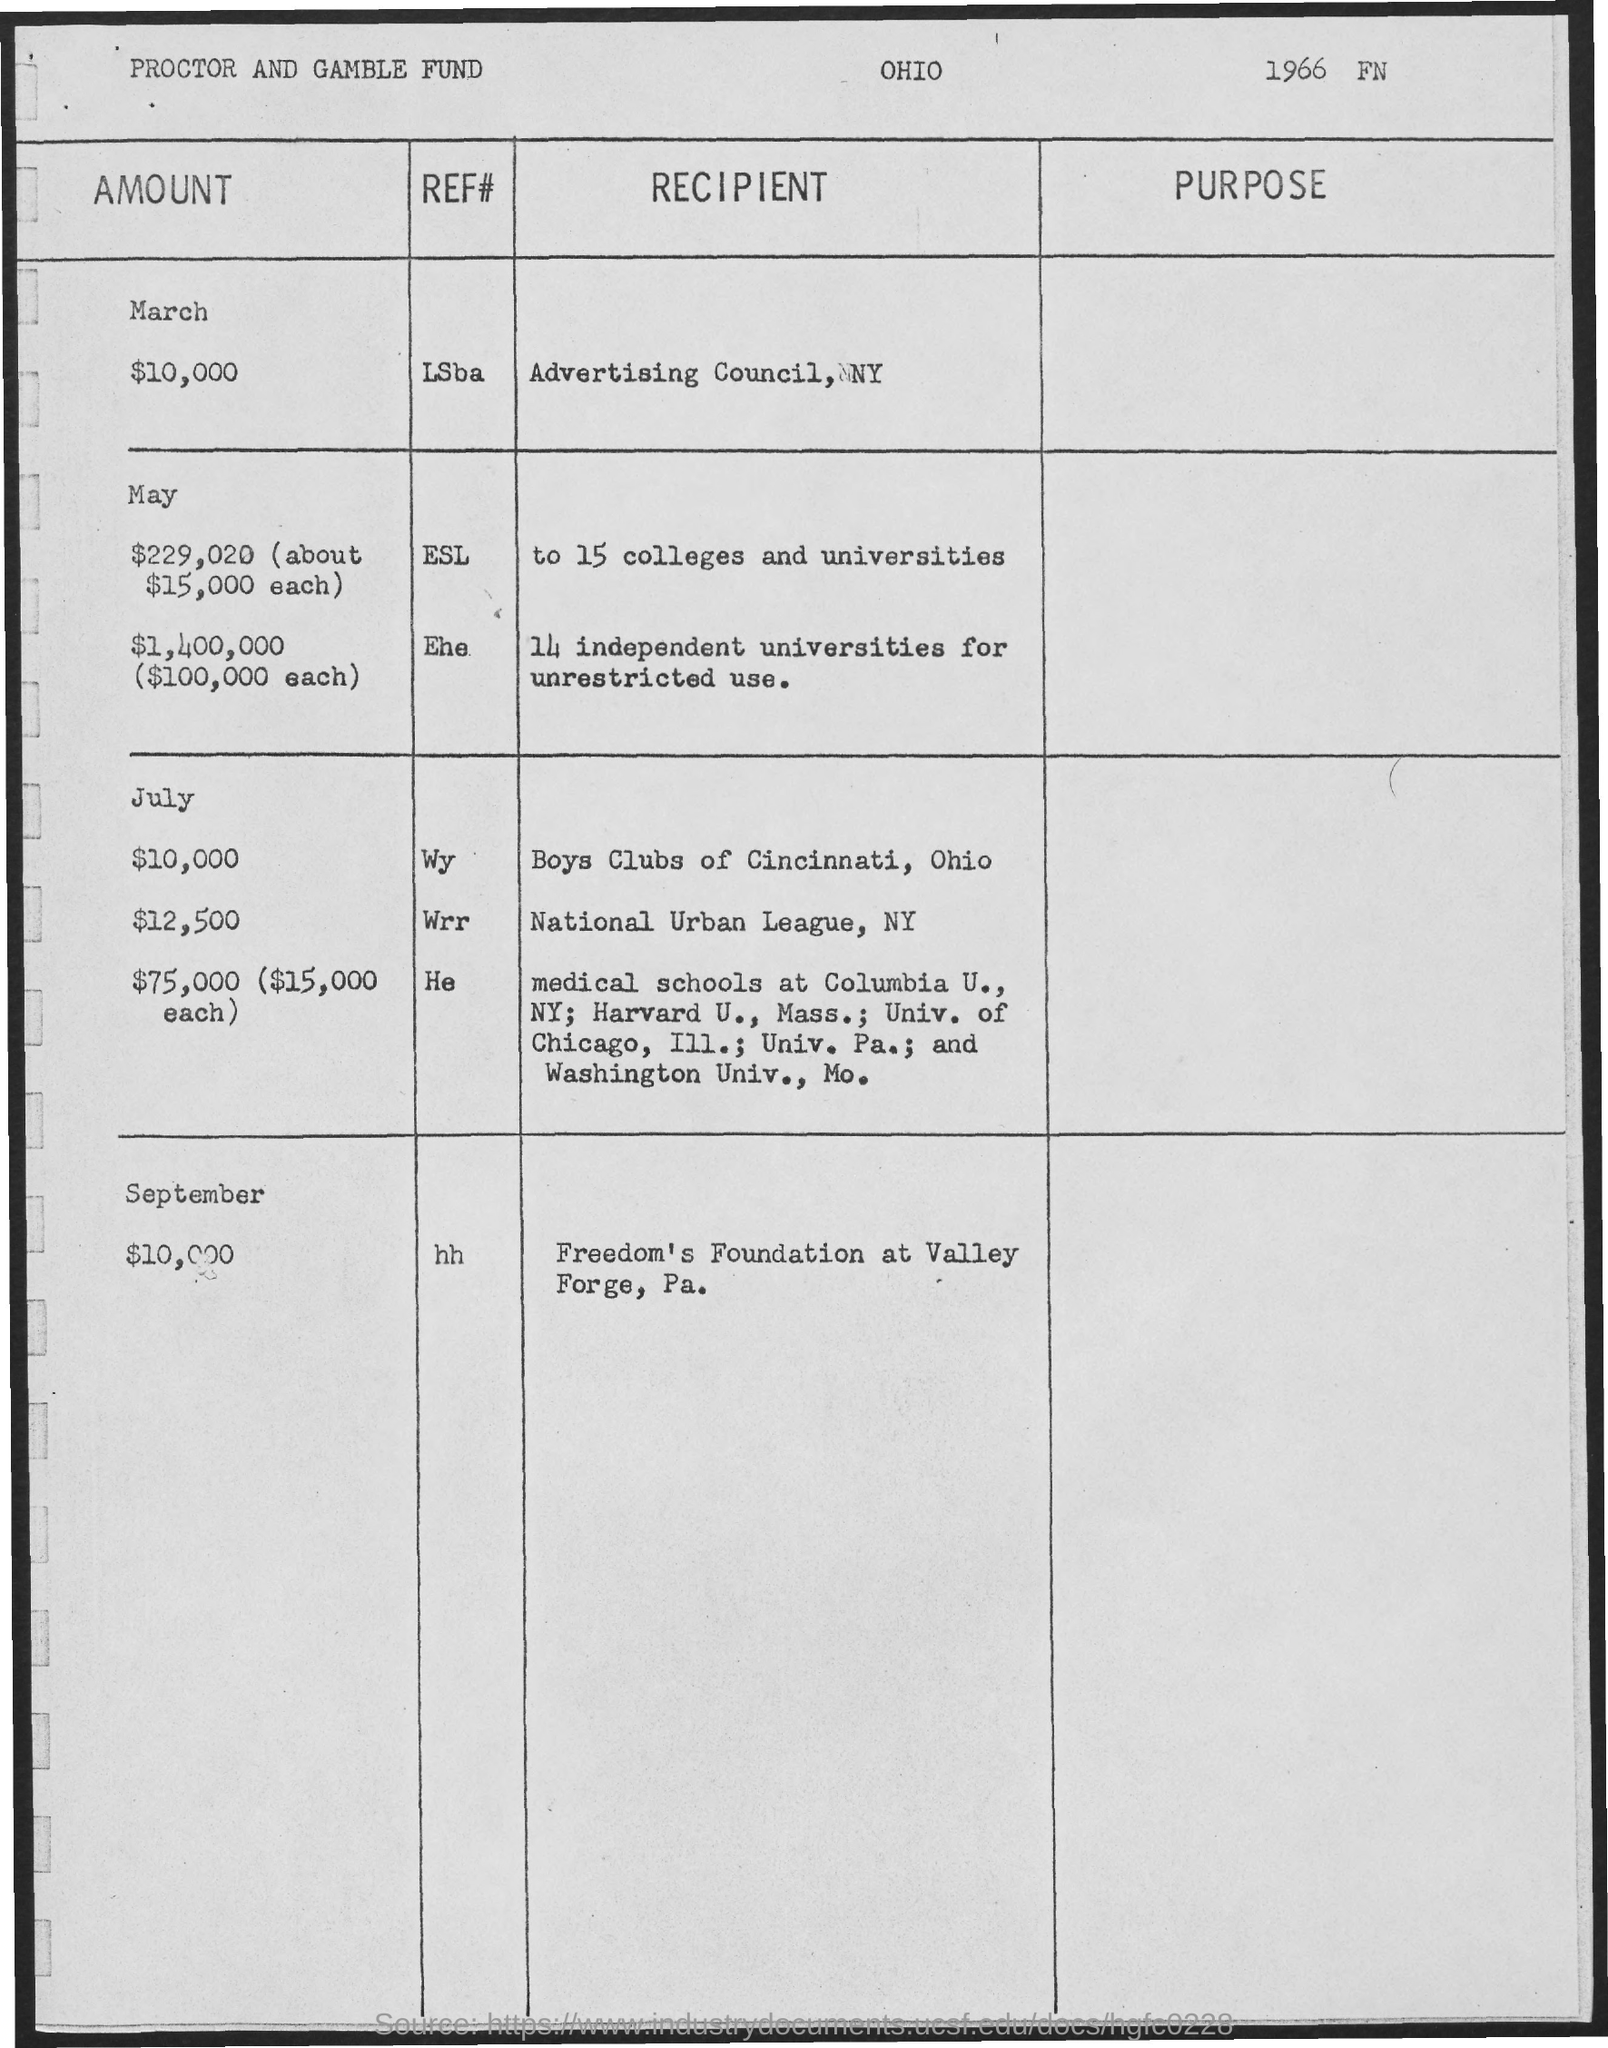What is the document about?
Provide a short and direct response. Proctor and Gamble Fund. In which month was fund given to 15 colleges and universities?
Give a very brief answer. May. Who was the recipient of $10,000 in September?
Ensure brevity in your answer.  Freedom's Foundation at Valley Forge, Pa. How much did Advertising Council, NY receive?
Your answer should be very brief. $10,000. 